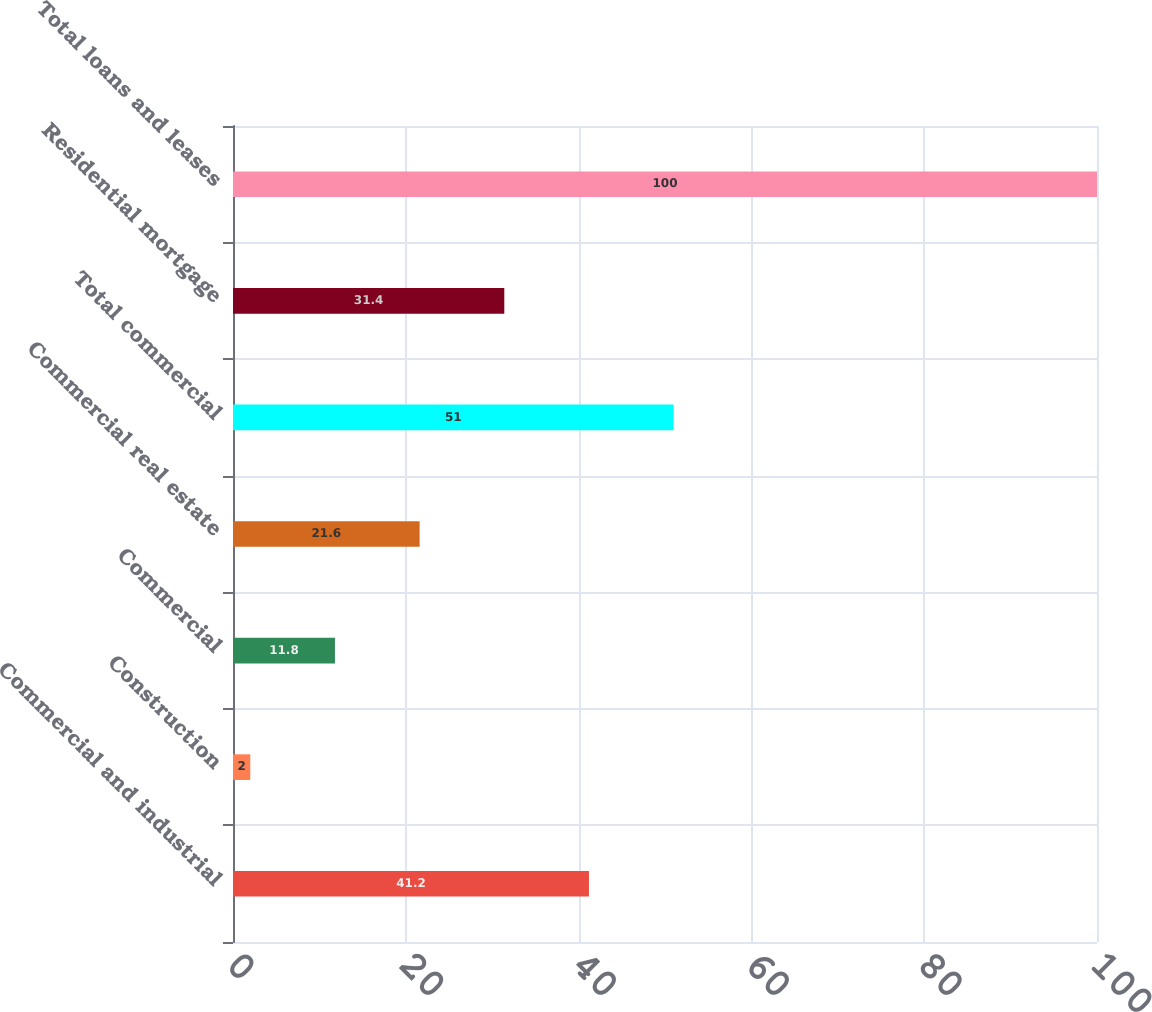Convert chart to OTSL. <chart><loc_0><loc_0><loc_500><loc_500><bar_chart><fcel>Commercial and industrial<fcel>Construction<fcel>Commercial<fcel>Commercial real estate<fcel>Total commercial<fcel>Residential mortgage<fcel>Total loans and leases<nl><fcel>41.2<fcel>2<fcel>11.8<fcel>21.6<fcel>51<fcel>31.4<fcel>100<nl></chart> 